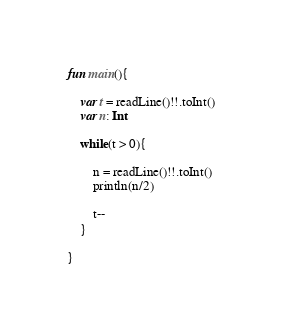<code> <loc_0><loc_0><loc_500><loc_500><_Kotlin_>fun main(){

    var t = readLine()!!.toInt()
    var n: Int

    while(t > 0){

        n = readLine()!!.toInt()
        println(n/2)

        t--
    }

}

</code> 